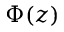<formula> <loc_0><loc_0><loc_500><loc_500>\Phi ( z )</formula> 